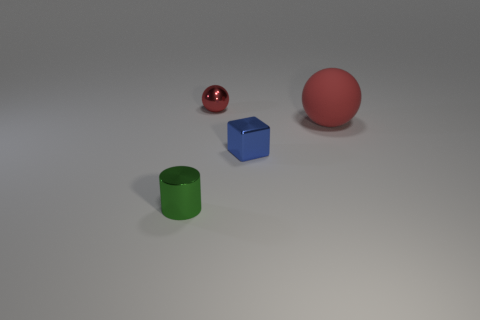Add 3 gray rubber cylinders. How many objects exist? 7 Subtract 1 balls. How many balls are left? 1 Subtract all large spheres. Subtract all red metal objects. How many objects are left? 2 Add 2 red matte objects. How many red matte objects are left? 3 Add 4 red rubber objects. How many red rubber objects exist? 5 Subtract 0 yellow cubes. How many objects are left? 4 Subtract all blocks. How many objects are left? 3 Subtract all gray cubes. Subtract all cyan balls. How many cubes are left? 1 